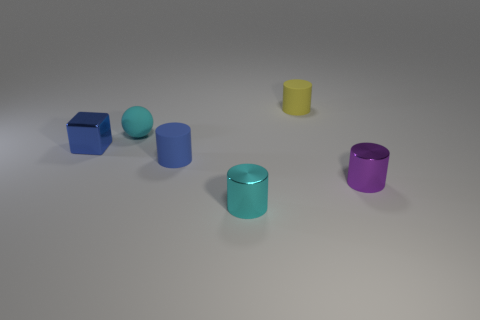Add 3 big yellow metallic balls. How many objects exist? 9 Subtract all yellow cylinders. How many cylinders are left? 3 Subtract all cyan cylinders. How many cylinders are left? 3 Subtract 1 cubes. How many cubes are left? 0 Subtract all purple cylinders. How many green blocks are left? 0 Subtract all small yellow things. Subtract all blue shiny cubes. How many objects are left? 4 Add 1 cyan things. How many cyan things are left? 3 Add 4 small green objects. How many small green objects exist? 4 Subtract 0 red spheres. How many objects are left? 6 Subtract all blocks. How many objects are left? 5 